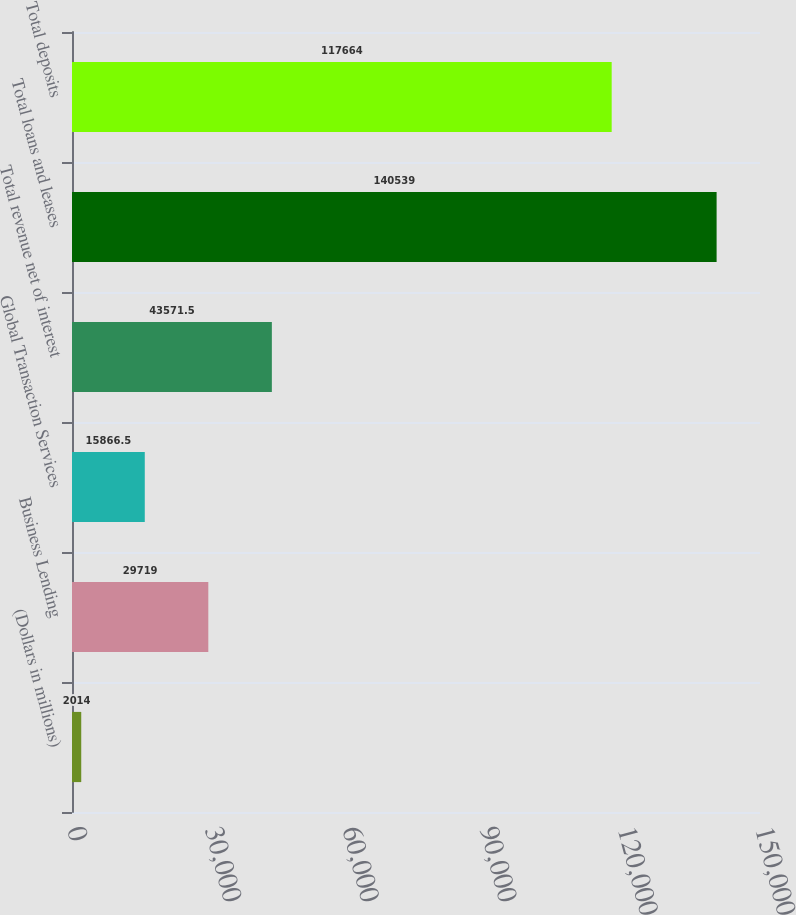Convert chart to OTSL. <chart><loc_0><loc_0><loc_500><loc_500><bar_chart><fcel>(Dollars in millions)<fcel>Business Lending<fcel>Global Transaction Services<fcel>Total revenue net of interest<fcel>Total loans and leases<fcel>Total deposits<nl><fcel>2014<fcel>29719<fcel>15866.5<fcel>43571.5<fcel>140539<fcel>117664<nl></chart> 